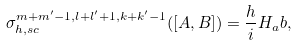<formula> <loc_0><loc_0><loc_500><loc_500>\sigma _ { h , s c } ^ { m + m ^ { \prime } - 1 , l + l ^ { \prime } + 1 , k + k ^ { \prime } - 1 } ( [ A , B ] ) = \frac { h } { i } H _ { a } b ,</formula> 